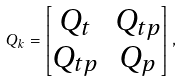Convert formula to latex. <formula><loc_0><loc_0><loc_500><loc_500>Q _ { k } = \begin{bmatrix} Q _ { t } & Q _ { t p } \\ Q _ { t p } & Q _ { p } \end{bmatrix} ,</formula> 